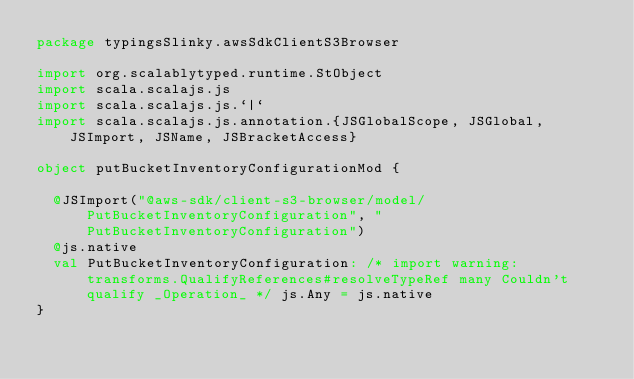Convert code to text. <code><loc_0><loc_0><loc_500><loc_500><_Scala_>package typingsSlinky.awsSdkClientS3Browser

import org.scalablytyped.runtime.StObject
import scala.scalajs.js
import scala.scalajs.js.`|`
import scala.scalajs.js.annotation.{JSGlobalScope, JSGlobal, JSImport, JSName, JSBracketAccess}

object putBucketInventoryConfigurationMod {
  
  @JSImport("@aws-sdk/client-s3-browser/model/PutBucketInventoryConfiguration", "PutBucketInventoryConfiguration")
  @js.native
  val PutBucketInventoryConfiguration: /* import warning: transforms.QualifyReferences#resolveTypeRef many Couldn't qualify _Operation_ */ js.Any = js.native
}
</code> 